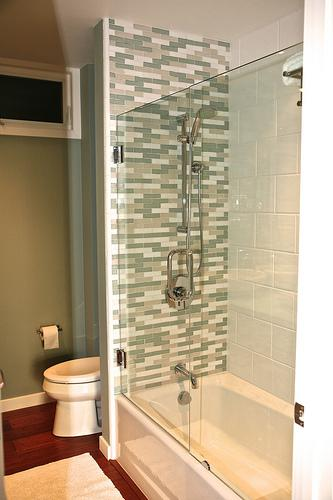Question: why is there a cat on the toilet?
Choices:
A. He is looking at the water.
B. He is using the toilet.
C. No cat.
D. The is jumping higher from it.
Answer with the letter. Answer: C Question: how many showers are there?
Choices:
A. None.
B. Two.
C. Three.
D. One.
Answer with the letter. Answer: D Question: what color is the floor?
Choices:
A. White.
B. Blue.
C. Brown.
D. Grey.
Answer with the letter. Answer: C Question: when did the girl fall asleep?
Choices:
A. No girl.
B. At 7.
C. At 8.
D. At 9.
Answer with the letter. Answer: A 